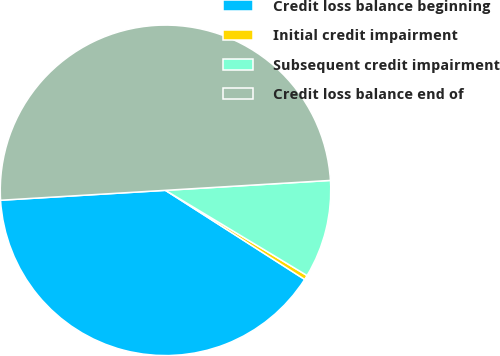Convert chart to OTSL. <chart><loc_0><loc_0><loc_500><loc_500><pie_chart><fcel>Credit loss balance beginning<fcel>Initial credit impairment<fcel>Subsequent credit impairment<fcel>Credit loss balance end of<nl><fcel>39.98%<fcel>0.44%<fcel>9.58%<fcel>50.0%<nl></chart> 